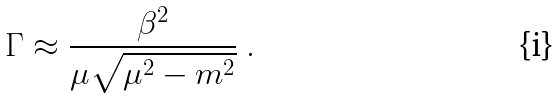Convert formula to latex. <formula><loc_0><loc_0><loc_500><loc_500>\Gamma \approx \frac { \beta ^ { 2 } } { \mu \sqrt { \mu ^ { 2 } - m ^ { 2 } } } \ .</formula> 